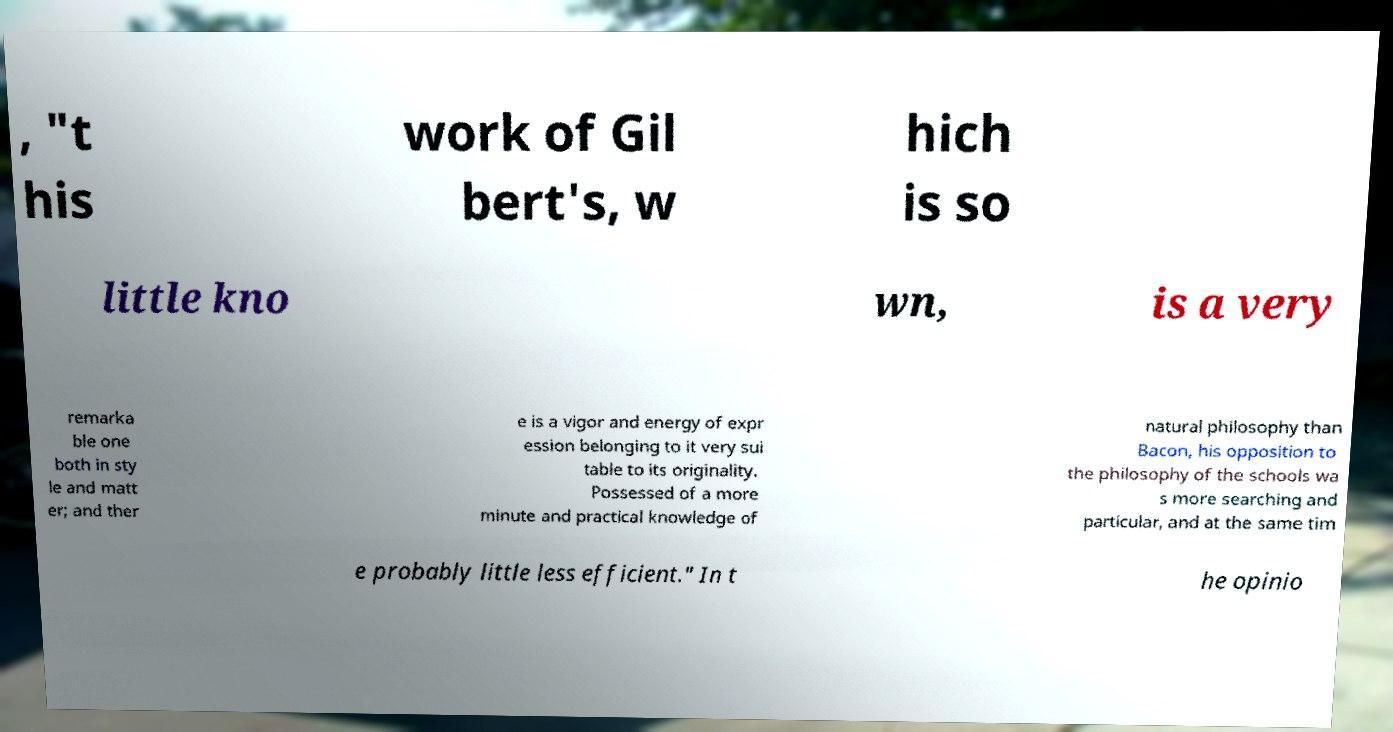Could you extract and type out the text from this image? , "t his work of Gil bert's, w hich is so little kno wn, is a very remarka ble one both in sty le and matt er; and ther e is a vigor and energy of expr ession belonging to it very sui table to its originality. Possessed of a more minute and practical knowledge of natural philosophy than Bacon, his opposition to the philosophy of the schools wa s more searching and particular, and at the same tim e probably little less efficient." In t he opinio 